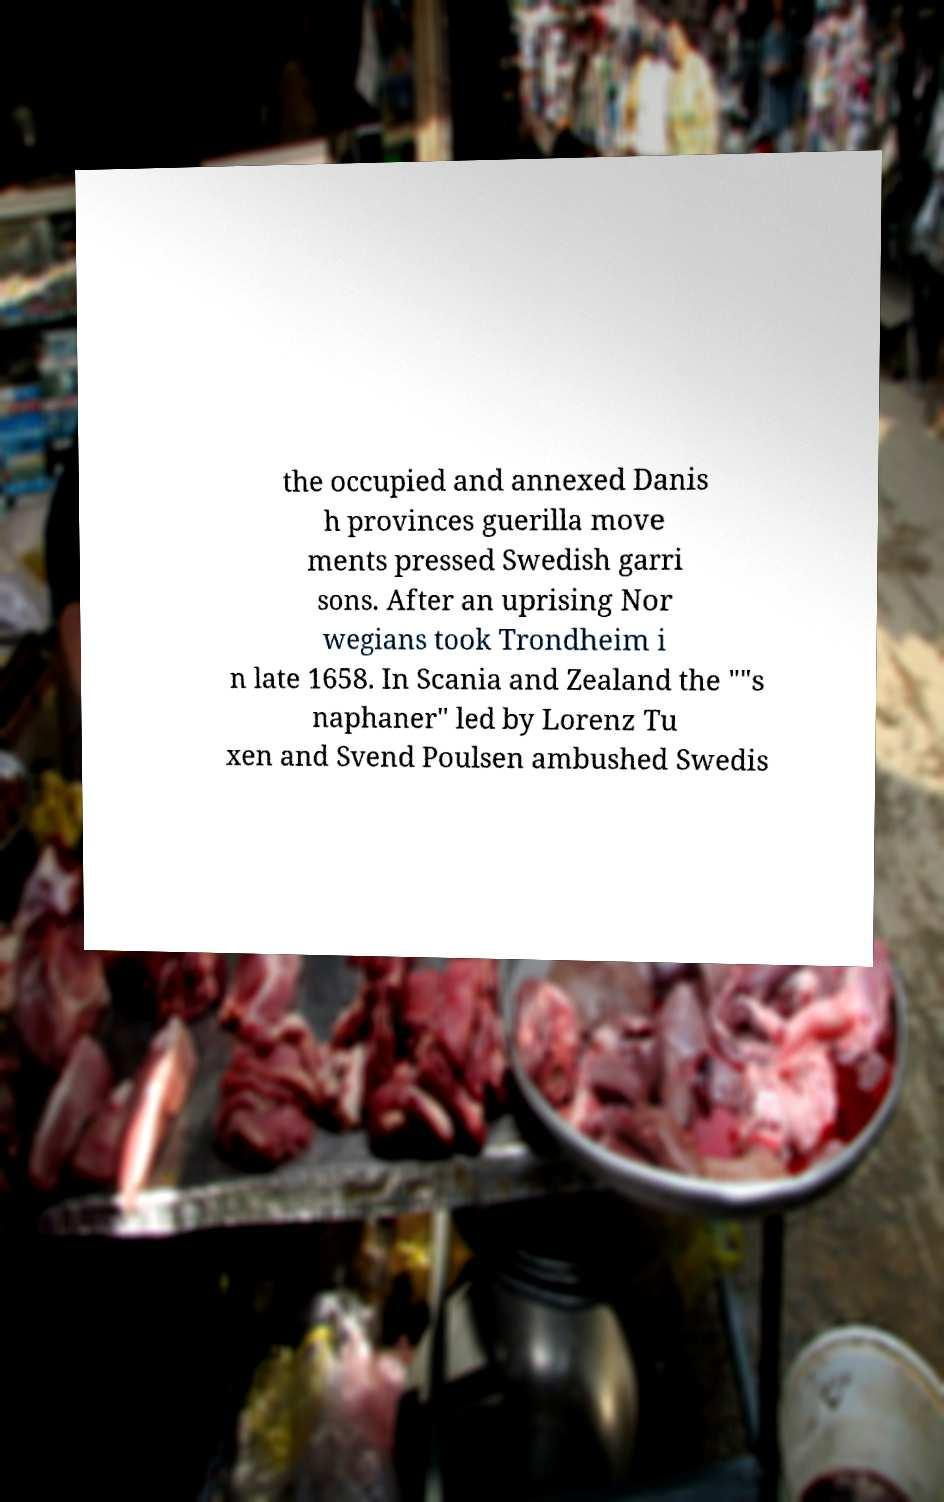Can you read and provide the text displayed in the image?This photo seems to have some interesting text. Can you extract and type it out for me? the occupied and annexed Danis h provinces guerilla move ments pressed Swedish garri sons. After an uprising Nor wegians took Trondheim i n late 1658. In Scania and Zealand the ""s naphaner" led by Lorenz Tu xen and Svend Poulsen ambushed Swedis 